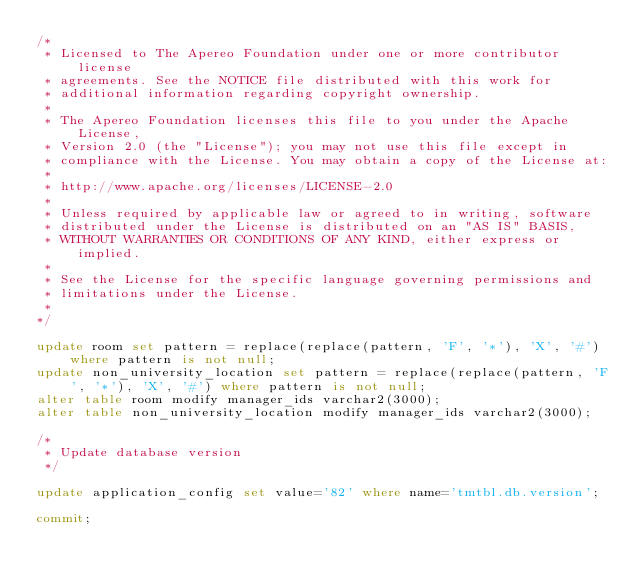<code> <loc_0><loc_0><loc_500><loc_500><_SQL_>/*
 * Licensed to The Apereo Foundation under one or more contributor license
 * agreements. See the NOTICE file distributed with this work for
 * additional information regarding copyright ownership.
 *
 * The Apereo Foundation licenses this file to you under the Apache License,
 * Version 2.0 (the "License"); you may not use this file except in
 * compliance with the License. You may obtain a copy of the License at:
 *
 * http://www.apache.org/licenses/LICENSE-2.0
 *
 * Unless required by applicable law or agreed to in writing, software
 * distributed under the License is distributed on an "AS IS" BASIS,
 * WITHOUT WARRANTIES OR CONDITIONS OF ANY KIND, either express or implied.
 *
 * See the License for the specific language governing permissions and
 * limitations under the License.
 * 
*/

update room set pattern = replace(replace(pattern, 'F', '*'), 'X', '#') where pattern is not null;
update non_university_location set pattern = replace(replace(pattern, 'F', '*'), 'X', '#') where pattern is not null;
alter table room modify manager_ids varchar2(3000);
alter table non_university_location modify manager_ids varchar2(3000);

/*
 * Update database version
 */

update application_config set value='82' where name='tmtbl.db.version';

commit;
</code> 